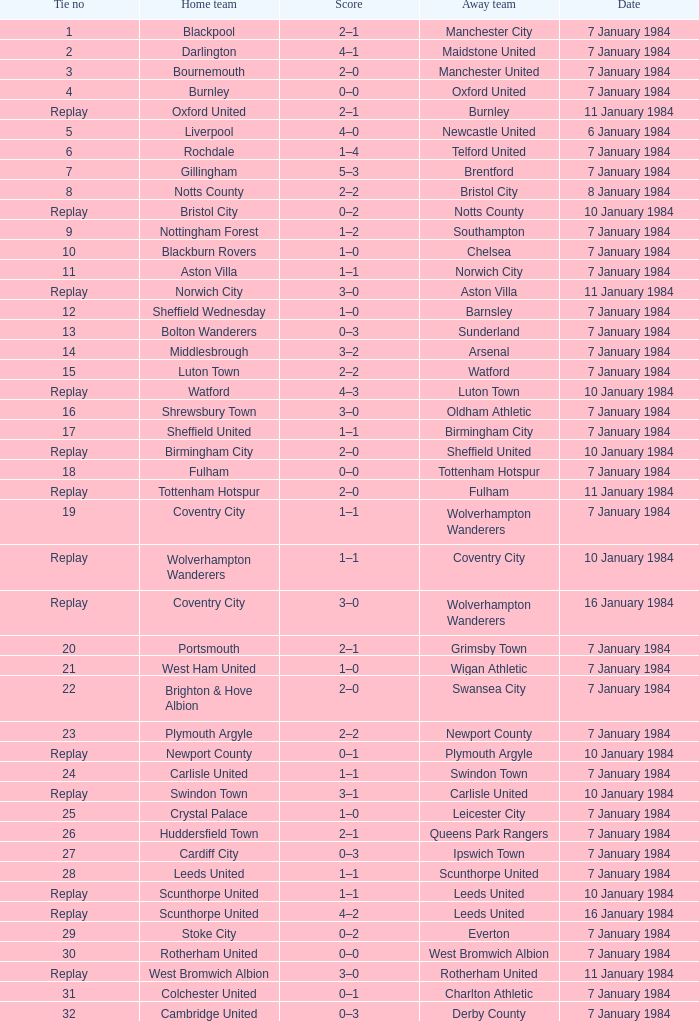Which visiting team had a tie of 14? Arsenal. 